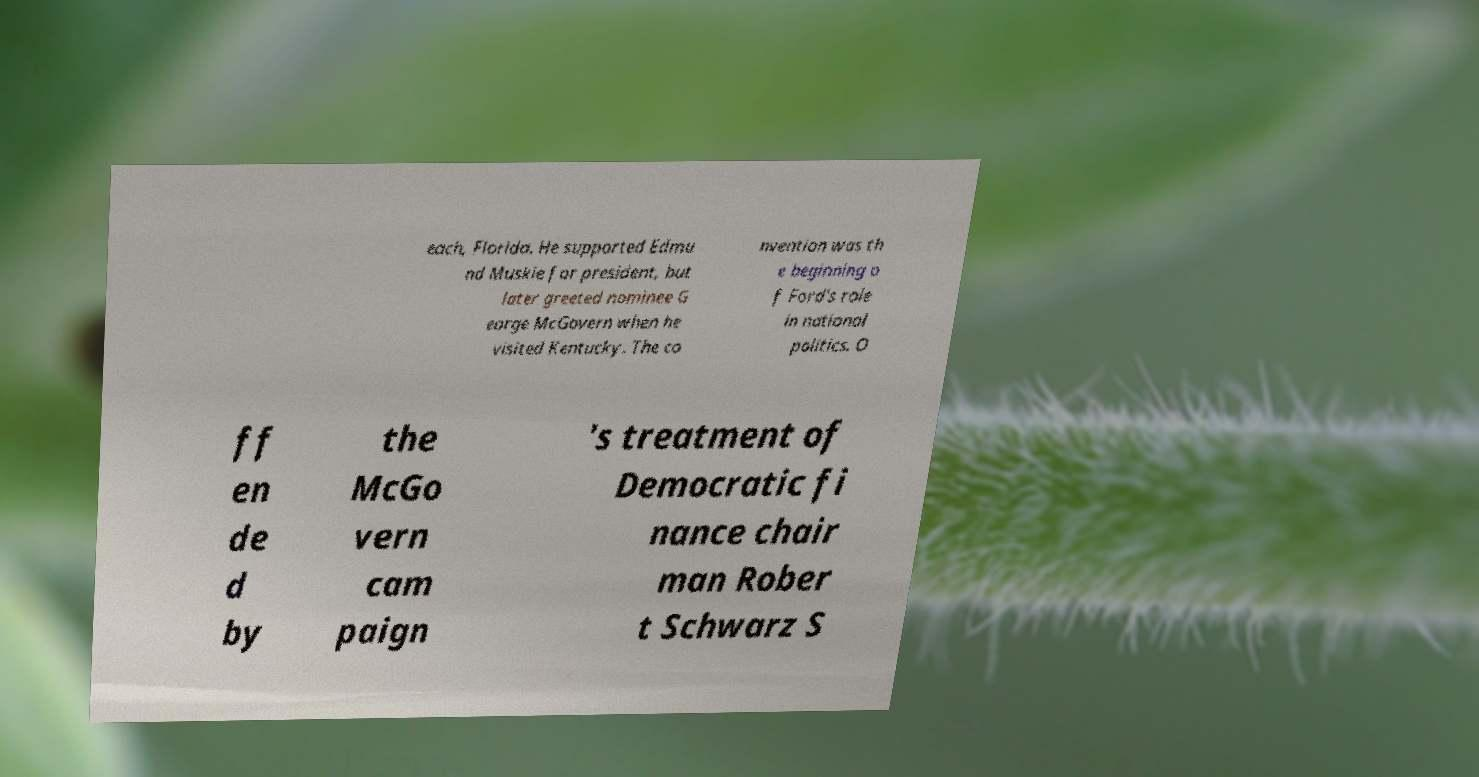There's text embedded in this image that I need extracted. Can you transcribe it verbatim? each, Florida. He supported Edmu nd Muskie for president, but later greeted nominee G eorge McGovern when he visited Kentucky. The co nvention was th e beginning o f Ford's role in national politics. O ff en de d by the McGo vern cam paign 's treatment of Democratic fi nance chair man Rober t Schwarz S 